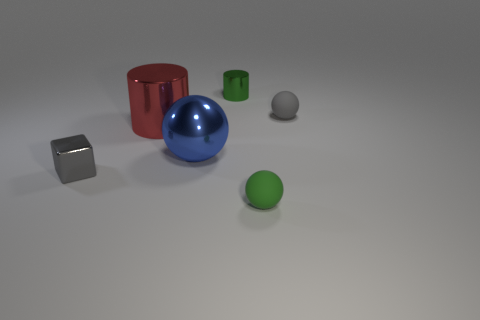Add 1 big purple things. How many objects exist? 7 Subtract all cubes. How many objects are left? 5 Subtract 0 yellow cylinders. How many objects are left? 6 Subtract all tiny green metallic cylinders. Subtract all blue objects. How many objects are left? 4 Add 3 gray things. How many gray things are left? 5 Add 5 large shiny cylinders. How many large shiny cylinders exist? 6 